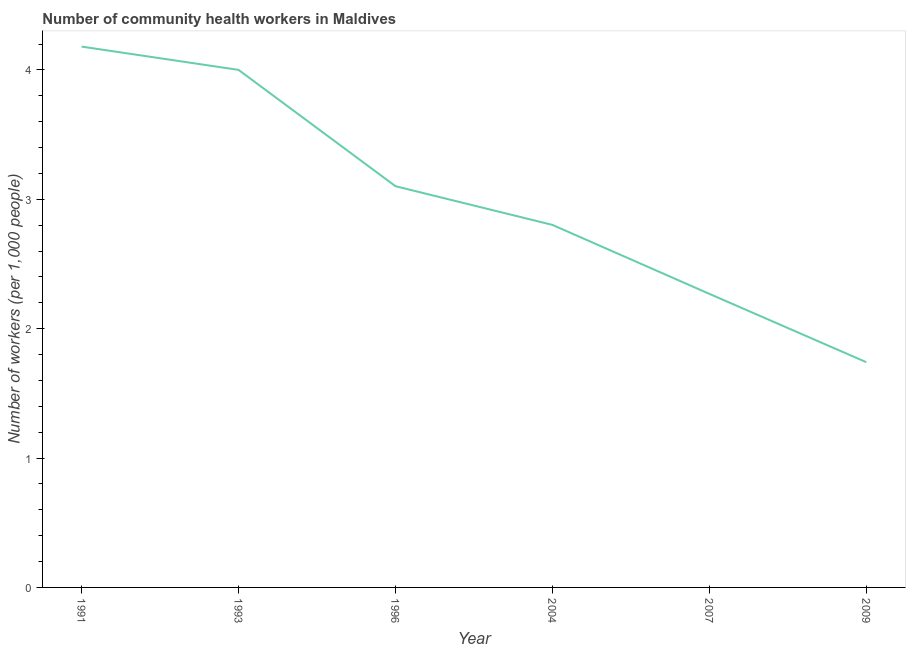What is the number of community health workers in 2004?
Provide a succinct answer. 2.8. Across all years, what is the maximum number of community health workers?
Your answer should be compact. 4.18. Across all years, what is the minimum number of community health workers?
Give a very brief answer. 1.74. In which year was the number of community health workers maximum?
Your answer should be very brief. 1991. In which year was the number of community health workers minimum?
Give a very brief answer. 2009. What is the sum of the number of community health workers?
Your answer should be very brief. 18.09. What is the difference between the number of community health workers in 1991 and 2004?
Your response must be concise. 1.38. What is the average number of community health workers per year?
Your answer should be very brief. 3.02. What is the median number of community health workers?
Your answer should be compact. 2.95. Do a majority of the years between 2007 and 1991 (inclusive) have number of community health workers greater than 2 ?
Offer a terse response. Yes. What is the ratio of the number of community health workers in 1991 to that in 2009?
Provide a succinct answer. 2.4. Is the number of community health workers in 1996 less than that in 2004?
Your response must be concise. No. Is the difference between the number of community health workers in 1993 and 2009 greater than the difference between any two years?
Keep it short and to the point. No. What is the difference between the highest and the second highest number of community health workers?
Make the answer very short. 0.18. Is the sum of the number of community health workers in 1993 and 2009 greater than the maximum number of community health workers across all years?
Provide a short and direct response. Yes. What is the difference between the highest and the lowest number of community health workers?
Provide a succinct answer. 2.44. Does the number of community health workers monotonically increase over the years?
Ensure brevity in your answer.  No. How many lines are there?
Your answer should be very brief. 1. Does the graph contain grids?
Provide a succinct answer. No. What is the title of the graph?
Your response must be concise. Number of community health workers in Maldives. What is the label or title of the Y-axis?
Offer a very short reply. Number of workers (per 1,0 people). What is the Number of workers (per 1,000 people) of 1991?
Provide a succinct answer. 4.18. What is the Number of workers (per 1,000 people) in 1996?
Provide a succinct answer. 3.1. What is the Number of workers (per 1,000 people) of 2004?
Keep it short and to the point. 2.8. What is the Number of workers (per 1,000 people) of 2007?
Provide a succinct answer. 2.27. What is the Number of workers (per 1,000 people) in 2009?
Your answer should be very brief. 1.74. What is the difference between the Number of workers (per 1,000 people) in 1991 and 1993?
Provide a succinct answer. 0.18. What is the difference between the Number of workers (per 1,000 people) in 1991 and 1996?
Give a very brief answer. 1.08. What is the difference between the Number of workers (per 1,000 people) in 1991 and 2004?
Offer a very short reply. 1.38. What is the difference between the Number of workers (per 1,000 people) in 1991 and 2007?
Your response must be concise. 1.91. What is the difference between the Number of workers (per 1,000 people) in 1991 and 2009?
Offer a very short reply. 2.44. What is the difference between the Number of workers (per 1,000 people) in 1993 and 1996?
Provide a short and direct response. 0.9. What is the difference between the Number of workers (per 1,000 people) in 1993 and 2004?
Provide a short and direct response. 1.2. What is the difference between the Number of workers (per 1,000 people) in 1993 and 2007?
Offer a terse response. 1.73. What is the difference between the Number of workers (per 1,000 people) in 1993 and 2009?
Give a very brief answer. 2.26. What is the difference between the Number of workers (per 1,000 people) in 1996 and 2004?
Ensure brevity in your answer.  0.3. What is the difference between the Number of workers (per 1,000 people) in 1996 and 2007?
Your answer should be very brief. 0.83. What is the difference between the Number of workers (per 1,000 people) in 1996 and 2009?
Offer a terse response. 1.36. What is the difference between the Number of workers (per 1,000 people) in 2004 and 2007?
Your answer should be very brief. 0.53. What is the difference between the Number of workers (per 1,000 people) in 2004 and 2009?
Your response must be concise. 1.06. What is the difference between the Number of workers (per 1,000 people) in 2007 and 2009?
Offer a terse response. 0.53. What is the ratio of the Number of workers (per 1,000 people) in 1991 to that in 1993?
Your response must be concise. 1.04. What is the ratio of the Number of workers (per 1,000 people) in 1991 to that in 1996?
Your answer should be very brief. 1.35. What is the ratio of the Number of workers (per 1,000 people) in 1991 to that in 2004?
Offer a terse response. 1.49. What is the ratio of the Number of workers (per 1,000 people) in 1991 to that in 2007?
Ensure brevity in your answer.  1.84. What is the ratio of the Number of workers (per 1,000 people) in 1991 to that in 2009?
Offer a very short reply. 2.4. What is the ratio of the Number of workers (per 1,000 people) in 1993 to that in 1996?
Offer a terse response. 1.29. What is the ratio of the Number of workers (per 1,000 people) in 1993 to that in 2004?
Your answer should be compact. 1.43. What is the ratio of the Number of workers (per 1,000 people) in 1993 to that in 2007?
Your answer should be very brief. 1.76. What is the ratio of the Number of workers (per 1,000 people) in 1993 to that in 2009?
Offer a very short reply. 2.3. What is the ratio of the Number of workers (per 1,000 people) in 1996 to that in 2004?
Give a very brief answer. 1.11. What is the ratio of the Number of workers (per 1,000 people) in 1996 to that in 2007?
Your response must be concise. 1.37. What is the ratio of the Number of workers (per 1,000 people) in 1996 to that in 2009?
Provide a succinct answer. 1.78. What is the ratio of the Number of workers (per 1,000 people) in 2004 to that in 2007?
Your answer should be compact. 1.24. What is the ratio of the Number of workers (per 1,000 people) in 2004 to that in 2009?
Ensure brevity in your answer.  1.61. What is the ratio of the Number of workers (per 1,000 people) in 2007 to that in 2009?
Provide a succinct answer. 1.3. 